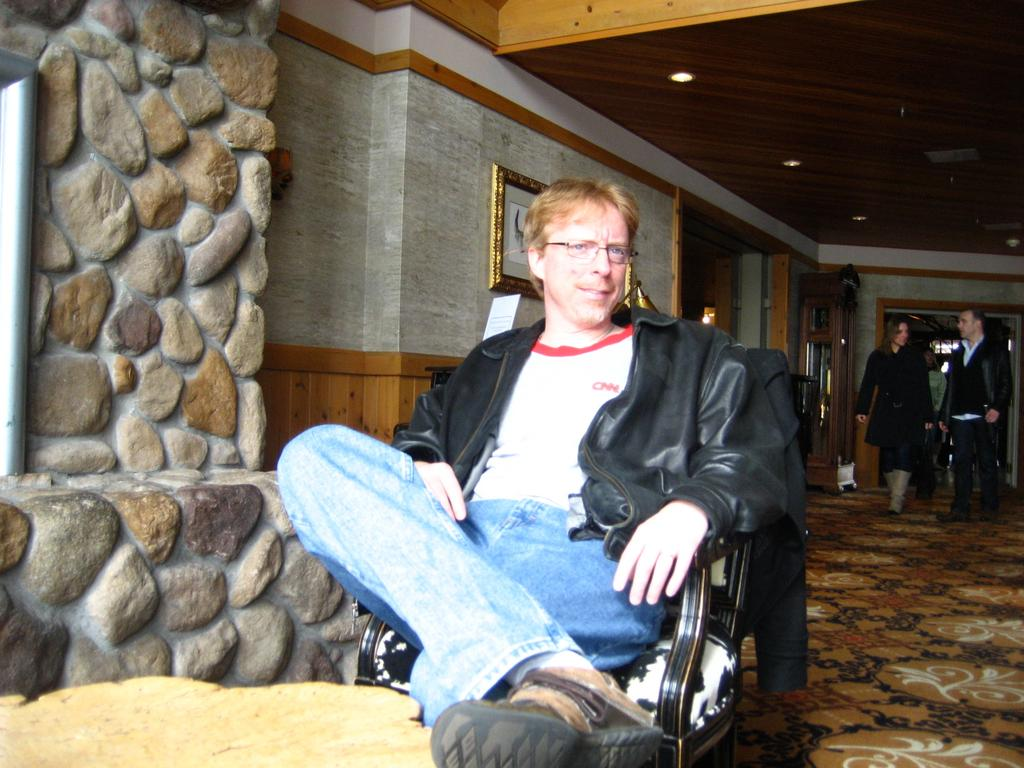What is the person in the image doing? The person is sitting on a chair in the image. What is the person wearing? The person is wearing a jacket. What can be seen in the background of the image? There are people walking and a wall in the background of the image. What is attached to the wall in the background? There is a photo frame attached to the wall in the background. How many babies are visible in the store in the image? There is no store or babies present in the image. What type of knot is being tied by the person in the image? There is no knot-tying activity visible in the image; the person is simply sitting on a chair. 